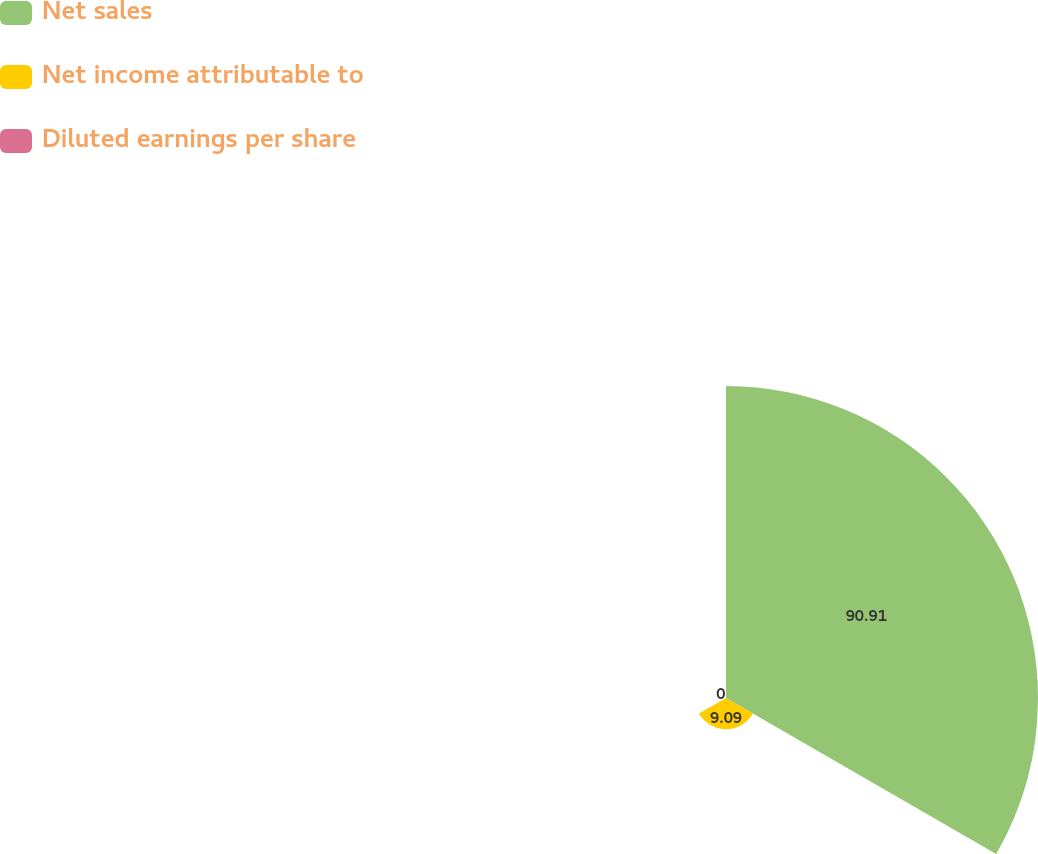<chart> <loc_0><loc_0><loc_500><loc_500><pie_chart><fcel>Net sales<fcel>Net income attributable to<fcel>Diluted earnings per share<nl><fcel>90.91%<fcel>9.09%<fcel>0.0%<nl></chart> 